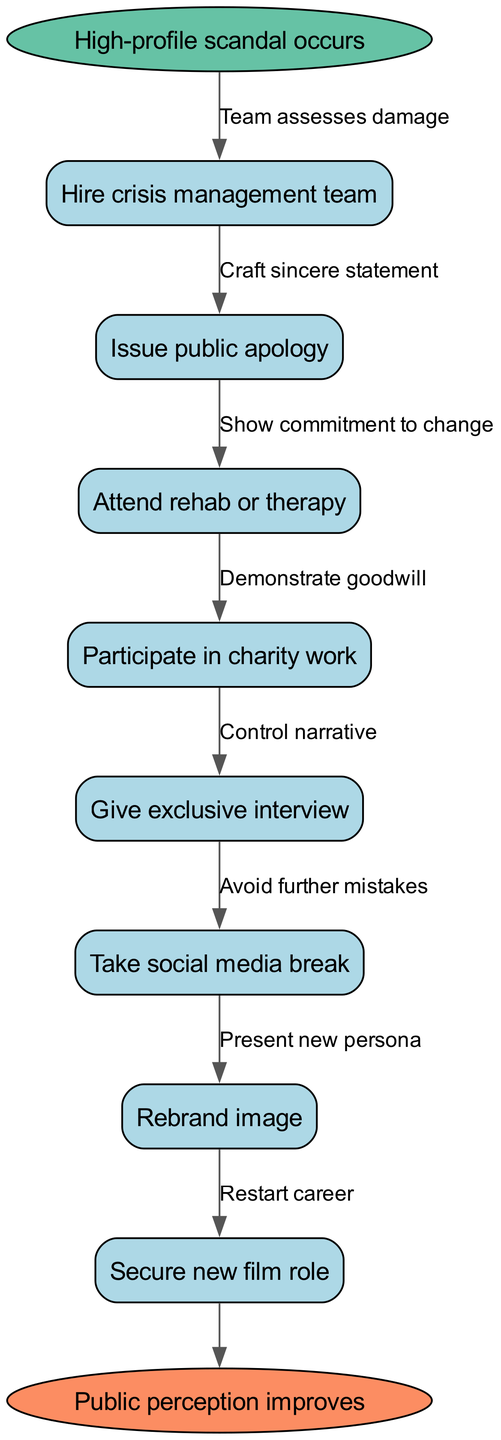What is the first action proposed after a scandal? The diagram starts with the node labeled "Hire crisis management team," which indicates the immediate action recommended to start the recovery process.
Answer: Hire crisis management team How many nodes are present in the diagram? The diagram lists a total of eight nodes, including the start and end nodes, as enumerated within the data structure.
Answer: 8 What is the last step before public perception improves? The final action before reaching the end node labeled "Public perception improves" is "Secure new film role," which highlights the preceding step in the recovery strategy.
Answer: Secure new film role Which node demonstrates a commitment to change? The node "Attend rehab or therapy" signifies a proactive step intended to show dedication to personal and professional change, as indicated by the corresponding edge.
Answer: Attend rehab or therapy What is the relationship between "Give exclusive interview" and "Control narrative"? The edge connects the node "Give exclusive interview" to the subsequent action, labeled "Control narrative," illustrating how the interview is meant to manage and shape public perceptions moving forward.
Answer: Control narrative What node follows "Issue public apology"? The flowchart indicates that "Attend rehab or therapy" comes right after "Issue public apology," showing the sequence of actions in the recovery plan.
Answer: Attend rehab or therapy How does charity work relate to reputation recovery? The node "Participate in charity work" is aimed at demonstrating goodwill, connecting as a strategy within the redemption process outlined in the diagram.
Answer: Demonstrate goodwill Which action is aimed at rebranding image? The node labeled "Rebrand image" specifically mentions the intention to alter public perception and can be identified directly in the diagram.
Answer: Rebrand image 